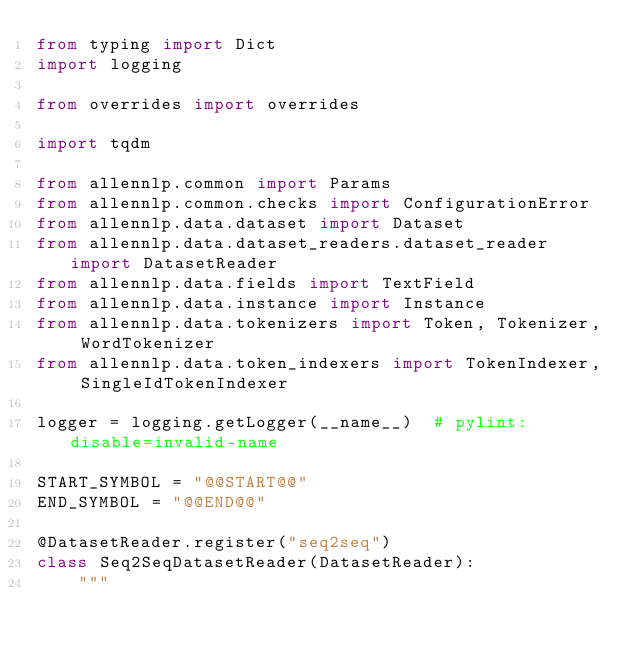Convert code to text. <code><loc_0><loc_0><loc_500><loc_500><_Python_>from typing import Dict
import logging

from overrides import overrides

import tqdm

from allennlp.common import Params
from allennlp.common.checks import ConfigurationError
from allennlp.data.dataset import Dataset
from allennlp.data.dataset_readers.dataset_reader import DatasetReader
from allennlp.data.fields import TextField
from allennlp.data.instance import Instance
from allennlp.data.tokenizers import Token, Tokenizer, WordTokenizer
from allennlp.data.token_indexers import TokenIndexer, SingleIdTokenIndexer

logger = logging.getLogger(__name__)  # pylint: disable=invalid-name

START_SYMBOL = "@@START@@"
END_SYMBOL = "@@END@@"

@DatasetReader.register("seq2seq")
class Seq2SeqDatasetReader(DatasetReader):
    """</code> 